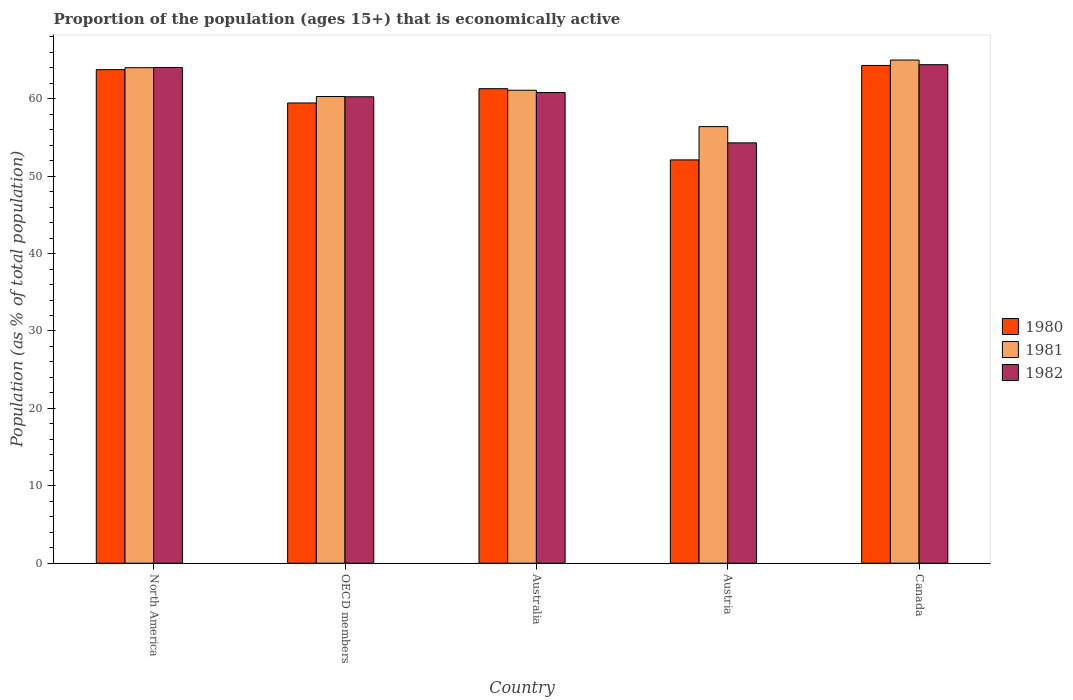How many different coloured bars are there?
Your response must be concise. 3. Are the number of bars per tick equal to the number of legend labels?
Offer a terse response. Yes. Are the number of bars on each tick of the X-axis equal?
Your answer should be very brief. Yes. How many bars are there on the 2nd tick from the right?
Your answer should be compact. 3. What is the label of the 3rd group of bars from the left?
Make the answer very short. Australia. In how many cases, is the number of bars for a given country not equal to the number of legend labels?
Make the answer very short. 0. What is the proportion of the population that is economically active in 1982 in Australia?
Provide a short and direct response. 60.8. Across all countries, what is the maximum proportion of the population that is economically active in 1982?
Provide a short and direct response. 64.4. Across all countries, what is the minimum proportion of the population that is economically active in 1980?
Offer a very short reply. 52.1. In which country was the proportion of the population that is economically active in 1980 maximum?
Offer a very short reply. Canada. In which country was the proportion of the population that is economically active in 1981 minimum?
Ensure brevity in your answer.  Austria. What is the total proportion of the population that is economically active in 1980 in the graph?
Your answer should be very brief. 300.91. What is the difference between the proportion of the population that is economically active in 1982 in Austria and that in OECD members?
Give a very brief answer. -5.95. What is the difference between the proportion of the population that is economically active in 1981 in North America and the proportion of the population that is economically active in 1982 in Australia?
Keep it short and to the point. 3.21. What is the average proportion of the population that is economically active in 1981 per country?
Your answer should be compact. 61.36. What is the difference between the proportion of the population that is economically active of/in 1980 and proportion of the population that is economically active of/in 1981 in North America?
Provide a succinct answer. -0.25. In how many countries, is the proportion of the population that is economically active in 1981 greater than 18 %?
Your answer should be compact. 5. What is the ratio of the proportion of the population that is economically active in 1982 in Austria to that in Canada?
Keep it short and to the point. 0.84. Is the proportion of the population that is economically active in 1980 in Australia less than that in Austria?
Keep it short and to the point. No. Is the difference between the proportion of the population that is economically active in 1980 in Australia and North America greater than the difference between the proportion of the population that is economically active in 1981 in Australia and North America?
Your answer should be compact. Yes. What is the difference between the highest and the second highest proportion of the population that is economically active in 1980?
Make the answer very short. 3. What is the difference between the highest and the lowest proportion of the population that is economically active in 1981?
Offer a very short reply. 8.6. In how many countries, is the proportion of the population that is economically active in 1981 greater than the average proportion of the population that is economically active in 1981 taken over all countries?
Provide a short and direct response. 2. What does the 2nd bar from the right in Austria represents?
Ensure brevity in your answer.  1981. Are all the bars in the graph horizontal?
Offer a very short reply. No. How many countries are there in the graph?
Your answer should be very brief. 5. What is the difference between two consecutive major ticks on the Y-axis?
Offer a terse response. 10. Where does the legend appear in the graph?
Your answer should be compact. Center right. What is the title of the graph?
Keep it short and to the point. Proportion of the population (ages 15+) that is economically active. Does "2008" appear as one of the legend labels in the graph?
Provide a short and direct response. No. What is the label or title of the X-axis?
Your answer should be compact. Country. What is the label or title of the Y-axis?
Your answer should be compact. Population (as % of total population). What is the Population (as % of total population) in 1980 in North America?
Ensure brevity in your answer.  63.76. What is the Population (as % of total population) of 1981 in North America?
Provide a succinct answer. 64.01. What is the Population (as % of total population) of 1982 in North America?
Give a very brief answer. 64.04. What is the Population (as % of total population) of 1980 in OECD members?
Your answer should be compact. 59.45. What is the Population (as % of total population) in 1981 in OECD members?
Offer a terse response. 60.29. What is the Population (as % of total population) in 1982 in OECD members?
Give a very brief answer. 60.25. What is the Population (as % of total population) of 1980 in Australia?
Offer a very short reply. 61.3. What is the Population (as % of total population) in 1981 in Australia?
Offer a terse response. 61.1. What is the Population (as % of total population) in 1982 in Australia?
Offer a very short reply. 60.8. What is the Population (as % of total population) in 1980 in Austria?
Keep it short and to the point. 52.1. What is the Population (as % of total population) in 1981 in Austria?
Your answer should be compact. 56.4. What is the Population (as % of total population) in 1982 in Austria?
Keep it short and to the point. 54.3. What is the Population (as % of total population) of 1980 in Canada?
Your answer should be compact. 64.3. What is the Population (as % of total population) in 1981 in Canada?
Provide a short and direct response. 65. What is the Population (as % of total population) of 1982 in Canada?
Give a very brief answer. 64.4. Across all countries, what is the maximum Population (as % of total population) of 1980?
Offer a terse response. 64.3. Across all countries, what is the maximum Population (as % of total population) in 1982?
Your answer should be very brief. 64.4. Across all countries, what is the minimum Population (as % of total population) in 1980?
Make the answer very short. 52.1. Across all countries, what is the minimum Population (as % of total population) in 1981?
Provide a succinct answer. 56.4. Across all countries, what is the minimum Population (as % of total population) of 1982?
Provide a short and direct response. 54.3. What is the total Population (as % of total population) in 1980 in the graph?
Offer a very short reply. 300.91. What is the total Population (as % of total population) in 1981 in the graph?
Your answer should be compact. 306.79. What is the total Population (as % of total population) in 1982 in the graph?
Offer a very short reply. 303.79. What is the difference between the Population (as % of total population) of 1980 in North America and that in OECD members?
Your answer should be very brief. 4.3. What is the difference between the Population (as % of total population) in 1981 in North America and that in OECD members?
Keep it short and to the point. 3.72. What is the difference between the Population (as % of total population) of 1982 in North America and that in OECD members?
Provide a succinct answer. 3.78. What is the difference between the Population (as % of total population) in 1980 in North America and that in Australia?
Your response must be concise. 2.46. What is the difference between the Population (as % of total population) of 1981 in North America and that in Australia?
Your answer should be very brief. 2.91. What is the difference between the Population (as % of total population) in 1982 in North America and that in Australia?
Offer a terse response. 3.24. What is the difference between the Population (as % of total population) of 1980 in North America and that in Austria?
Offer a very short reply. 11.66. What is the difference between the Population (as % of total population) of 1981 in North America and that in Austria?
Provide a succinct answer. 7.61. What is the difference between the Population (as % of total population) in 1982 in North America and that in Austria?
Offer a terse response. 9.74. What is the difference between the Population (as % of total population) in 1980 in North America and that in Canada?
Offer a terse response. -0.54. What is the difference between the Population (as % of total population) of 1981 in North America and that in Canada?
Your answer should be compact. -0.99. What is the difference between the Population (as % of total population) in 1982 in North America and that in Canada?
Give a very brief answer. -0.36. What is the difference between the Population (as % of total population) in 1980 in OECD members and that in Australia?
Ensure brevity in your answer.  -1.85. What is the difference between the Population (as % of total population) in 1981 in OECD members and that in Australia?
Provide a succinct answer. -0.81. What is the difference between the Population (as % of total population) of 1982 in OECD members and that in Australia?
Offer a terse response. -0.55. What is the difference between the Population (as % of total population) in 1980 in OECD members and that in Austria?
Offer a very short reply. 7.35. What is the difference between the Population (as % of total population) in 1981 in OECD members and that in Austria?
Your response must be concise. 3.89. What is the difference between the Population (as % of total population) of 1982 in OECD members and that in Austria?
Give a very brief answer. 5.95. What is the difference between the Population (as % of total population) of 1980 in OECD members and that in Canada?
Your response must be concise. -4.85. What is the difference between the Population (as % of total population) in 1981 in OECD members and that in Canada?
Your response must be concise. -4.71. What is the difference between the Population (as % of total population) of 1982 in OECD members and that in Canada?
Make the answer very short. -4.15. What is the difference between the Population (as % of total population) in 1980 in Australia and that in Austria?
Offer a terse response. 9.2. What is the difference between the Population (as % of total population) of 1981 in Australia and that in Austria?
Offer a very short reply. 4.7. What is the difference between the Population (as % of total population) of 1982 in Australia and that in Austria?
Provide a succinct answer. 6.5. What is the difference between the Population (as % of total population) of 1980 in Austria and that in Canada?
Provide a short and direct response. -12.2. What is the difference between the Population (as % of total population) of 1982 in Austria and that in Canada?
Ensure brevity in your answer.  -10.1. What is the difference between the Population (as % of total population) in 1980 in North America and the Population (as % of total population) in 1981 in OECD members?
Provide a short and direct response. 3.47. What is the difference between the Population (as % of total population) in 1980 in North America and the Population (as % of total population) in 1982 in OECD members?
Offer a very short reply. 3.5. What is the difference between the Population (as % of total population) of 1981 in North America and the Population (as % of total population) of 1982 in OECD members?
Give a very brief answer. 3.75. What is the difference between the Population (as % of total population) in 1980 in North America and the Population (as % of total population) in 1981 in Australia?
Provide a short and direct response. 2.66. What is the difference between the Population (as % of total population) in 1980 in North America and the Population (as % of total population) in 1982 in Australia?
Provide a short and direct response. 2.96. What is the difference between the Population (as % of total population) in 1981 in North America and the Population (as % of total population) in 1982 in Australia?
Your answer should be compact. 3.21. What is the difference between the Population (as % of total population) in 1980 in North America and the Population (as % of total population) in 1981 in Austria?
Offer a very short reply. 7.36. What is the difference between the Population (as % of total population) of 1980 in North America and the Population (as % of total population) of 1982 in Austria?
Ensure brevity in your answer.  9.46. What is the difference between the Population (as % of total population) of 1981 in North America and the Population (as % of total population) of 1982 in Austria?
Your response must be concise. 9.71. What is the difference between the Population (as % of total population) of 1980 in North America and the Population (as % of total population) of 1981 in Canada?
Keep it short and to the point. -1.24. What is the difference between the Population (as % of total population) of 1980 in North America and the Population (as % of total population) of 1982 in Canada?
Your answer should be very brief. -0.64. What is the difference between the Population (as % of total population) of 1981 in North America and the Population (as % of total population) of 1982 in Canada?
Offer a very short reply. -0.39. What is the difference between the Population (as % of total population) in 1980 in OECD members and the Population (as % of total population) in 1981 in Australia?
Offer a terse response. -1.65. What is the difference between the Population (as % of total population) in 1980 in OECD members and the Population (as % of total population) in 1982 in Australia?
Provide a succinct answer. -1.35. What is the difference between the Population (as % of total population) in 1981 in OECD members and the Population (as % of total population) in 1982 in Australia?
Your answer should be compact. -0.51. What is the difference between the Population (as % of total population) in 1980 in OECD members and the Population (as % of total population) in 1981 in Austria?
Offer a terse response. 3.05. What is the difference between the Population (as % of total population) of 1980 in OECD members and the Population (as % of total population) of 1982 in Austria?
Give a very brief answer. 5.15. What is the difference between the Population (as % of total population) of 1981 in OECD members and the Population (as % of total population) of 1982 in Austria?
Your answer should be compact. 5.99. What is the difference between the Population (as % of total population) of 1980 in OECD members and the Population (as % of total population) of 1981 in Canada?
Ensure brevity in your answer.  -5.55. What is the difference between the Population (as % of total population) in 1980 in OECD members and the Population (as % of total population) in 1982 in Canada?
Provide a short and direct response. -4.95. What is the difference between the Population (as % of total population) of 1981 in OECD members and the Population (as % of total population) of 1982 in Canada?
Your answer should be compact. -4.11. What is the difference between the Population (as % of total population) in 1980 in Australia and the Population (as % of total population) in 1981 in Austria?
Offer a terse response. 4.9. What is the difference between the Population (as % of total population) in 1981 in Australia and the Population (as % of total population) in 1982 in Austria?
Your answer should be compact. 6.8. What is the difference between the Population (as % of total population) in 1980 in Australia and the Population (as % of total population) in 1981 in Canada?
Provide a succinct answer. -3.7. What is the difference between the Population (as % of total population) of 1980 in Australia and the Population (as % of total population) of 1982 in Canada?
Give a very brief answer. -3.1. What is the difference between the Population (as % of total population) of 1981 in Australia and the Population (as % of total population) of 1982 in Canada?
Your answer should be very brief. -3.3. What is the difference between the Population (as % of total population) in 1980 in Austria and the Population (as % of total population) in 1981 in Canada?
Keep it short and to the point. -12.9. What is the difference between the Population (as % of total population) in 1981 in Austria and the Population (as % of total population) in 1982 in Canada?
Offer a terse response. -8. What is the average Population (as % of total population) of 1980 per country?
Provide a short and direct response. 60.18. What is the average Population (as % of total population) of 1981 per country?
Offer a terse response. 61.36. What is the average Population (as % of total population) of 1982 per country?
Make the answer very short. 60.76. What is the difference between the Population (as % of total population) in 1980 and Population (as % of total population) in 1981 in North America?
Offer a very short reply. -0.25. What is the difference between the Population (as % of total population) of 1980 and Population (as % of total population) of 1982 in North America?
Give a very brief answer. -0.28. What is the difference between the Population (as % of total population) of 1981 and Population (as % of total population) of 1982 in North America?
Your answer should be very brief. -0.03. What is the difference between the Population (as % of total population) of 1980 and Population (as % of total population) of 1981 in OECD members?
Make the answer very short. -0.83. What is the difference between the Population (as % of total population) in 1980 and Population (as % of total population) in 1982 in OECD members?
Offer a very short reply. -0.8. What is the difference between the Population (as % of total population) of 1981 and Population (as % of total population) of 1982 in OECD members?
Provide a short and direct response. 0.03. What is the difference between the Population (as % of total population) of 1980 and Population (as % of total population) of 1982 in Australia?
Give a very brief answer. 0.5. What is the difference between the Population (as % of total population) in 1981 and Population (as % of total population) in 1982 in Australia?
Make the answer very short. 0.3. What is the difference between the Population (as % of total population) of 1980 and Population (as % of total population) of 1981 in Austria?
Make the answer very short. -4.3. What is the difference between the Population (as % of total population) of 1980 and Population (as % of total population) of 1982 in Canada?
Your response must be concise. -0.1. What is the difference between the Population (as % of total population) of 1981 and Population (as % of total population) of 1982 in Canada?
Your answer should be compact. 0.6. What is the ratio of the Population (as % of total population) in 1980 in North America to that in OECD members?
Offer a very short reply. 1.07. What is the ratio of the Population (as % of total population) of 1981 in North America to that in OECD members?
Provide a succinct answer. 1.06. What is the ratio of the Population (as % of total population) in 1982 in North America to that in OECD members?
Offer a terse response. 1.06. What is the ratio of the Population (as % of total population) in 1980 in North America to that in Australia?
Give a very brief answer. 1.04. What is the ratio of the Population (as % of total population) of 1981 in North America to that in Australia?
Ensure brevity in your answer.  1.05. What is the ratio of the Population (as % of total population) of 1982 in North America to that in Australia?
Your answer should be compact. 1.05. What is the ratio of the Population (as % of total population) in 1980 in North America to that in Austria?
Provide a succinct answer. 1.22. What is the ratio of the Population (as % of total population) in 1981 in North America to that in Austria?
Keep it short and to the point. 1.13. What is the ratio of the Population (as % of total population) in 1982 in North America to that in Austria?
Offer a terse response. 1.18. What is the ratio of the Population (as % of total population) of 1981 in North America to that in Canada?
Give a very brief answer. 0.98. What is the ratio of the Population (as % of total population) in 1980 in OECD members to that in Australia?
Ensure brevity in your answer.  0.97. What is the ratio of the Population (as % of total population) of 1981 in OECD members to that in Australia?
Your answer should be compact. 0.99. What is the ratio of the Population (as % of total population) of 1982 in OECD members to that in Australia?
Ensure brevity in your answer.  0.99. What is the ratio of the Population (as % of total population) of 1980 in OECD members to that in Austria?
Your response must be concise. 1.14. What is the ratio of the Population (as % of total population) of 1981 in OECD members to that in Austria?
Make the answer very short. 1.07. What is the ratio of the Population (as % of total population) in 1982 in OECD members to that in Austria?
Offer a very short reply. 1.11. What is the ratio of the Population (as % of total population) of 1980 in OECD members to that in Canada?
Provide a short and direct response. 0.92. What is the ratio of the Population (as % of total population) in 1981 in OECD members to that in Canada?
Make the answer very short. 0.93. What is the ratio of the Population (as % of total population) of 1982 in OECD members to that in Canada?
Give a very brief answer. 0.94. What is the ratio of the Population (as % of total population) of 1980 in Australia to that in Austria?
Keep it short and to the point. 1.18. What is the ratio of the Population (as % of total population) of 1982 in Australia to that in Austria?
Make the answer very short. 1.12. What is the ratio of the Population (as % of total population) of 1980 in Australia to that in Canada?
Your response must be concise. 0.95. What is the ratio of the Population (as % of total population) in 1981 in Australia to that in Canada?
Your answer should be very brief. 0.94. What is the ratio of the Population (as % of total population) in 1982 in Australia to that in Canada?
Ensure brevity in your answer.  0.94. What is the ratio of the Population (as % of total population) in 1980 in Austria to that in Canada?
Your response must be concise. 0.81. What is the ratio of the Population (as % of total population) in 1981 in Austria to that in Canada?
Make the answer very short. 0.87. What is the ratio of the Population (as % of total population) of 1982 in Austria to that in Canada?
Keep it short and to the point. 0.84. What is the difference between the highest and the second highest Population (as % of total population) of 1980?
Your response must be concise. 0.54. What is the difference between the highest and the second highest Population (as % of total population) in 1981?
Keep it short and to the point. 0.99. What is the difference between the highest and the second highest Population (as % of total population) of 1982?
Your answer should be very brief. 0.36. What is the difference between the highest and the lowest Population (as % of total population) of 1981?
Ensure brevity in your answer.  8.6. What is the difference between the highest and the lowest Population (as % of total population) in 1982?
Ensure brevity in your answer.  10.1. 